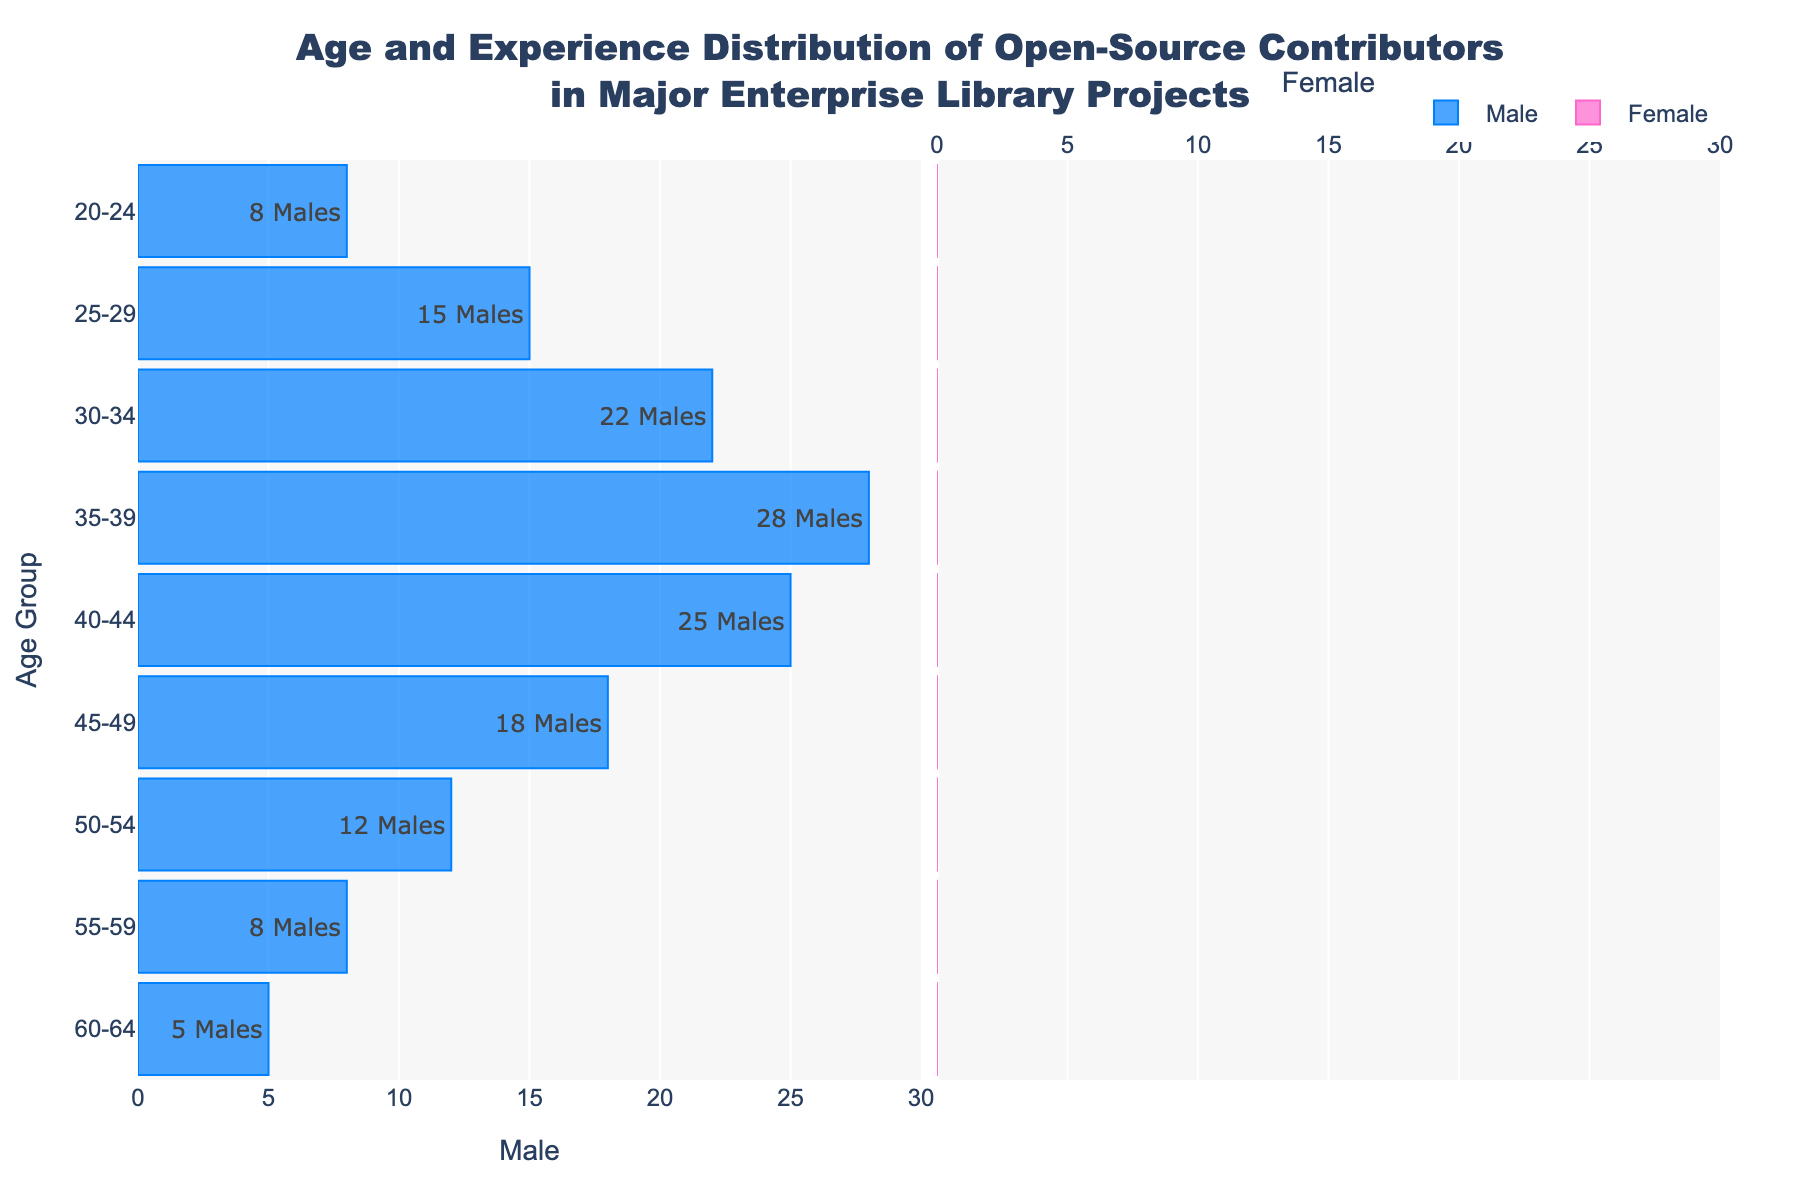What is the age group with the highest number of male contributors? The highest bar on the male (left) side of the pyramid corresponds to the age group 35-39.
Answer: 35-39 How many female contributors are in the 25-29 age group? The height of the female (right) bar for the 25-29 age group indicates there are 12 female contributors.
Answer: 12 What is the total number of contributors in the 40-44 age group? Sum the number of male (25) and female (15) contributors in the 40-44 age group (25 + 15 = 40).
Answer: 40 Which gender has more contributors in the 20-24 age group? Compare the heights of the male (left) and female (right) bars for the 20-24 age group: males have 8 contributors whereas females have 5.
Answer: Male What is the total number of male participants across all age groups? Sum the number of male contributors in each age group: (8 + 15 + 22 + 28 + 25 + 18 + 12 + 8 + 5) = 141.
Answer: 141 How does the number of contributors in the 30-34 age group compare between males and females? Examine the heights of the respective bars: males have 22 and females have 18, a difference of 4 more males.
Answer: 4 more males What percentage of the total contributors in the 50-54 age group are females? First, find the total contributors in the 50-54 age group: (12 males + 7 females) = 19. Then, calculate the percentage of females: (7 / 19) * 100 ≈ 36.84%.
Answer: 36.84% What insights can you derive about the gender distribution of contributors in their late 30s across the projects? From the age group 35-39 data: there are 28 male and 20 female contributors. It appears that this age group has a relatively high number of both male and female contributors, with males predominant. This indicates significant involvement from middle-aged contributors with males leading.
Answer: Predominantly male, high mid-30s involvement 